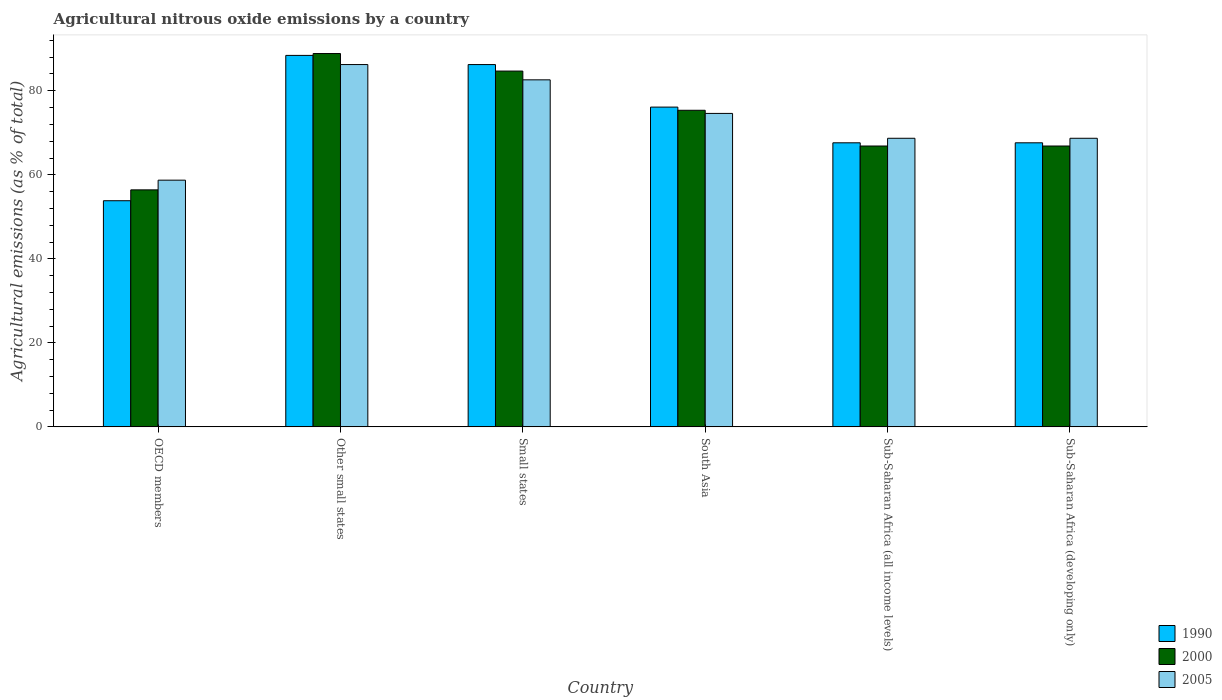Are the number of bars per tick equal to the number of legend labels?
Your response must be concise. Yes. Are the number of bars on each tick of the X-axis equal?
Your answer should be compact. Yes. How many bars are there on the 3rd tick from the left?
Make the answer very short. 3. What is the label of the 2nd group of bars from the left?
Offer a terse response. Other small states. In how many cases, is the number of bars for a given country not equal to the number of legend labels?
Provide a short and direct response. 0. What is the amount of agricultural nitrous oxide emitted in 2005 in OECD members?
Your response must be concise. 58.73. Across all countries, what is the maximum amount of agricultural nitrous oxide emitted in 1990?
Your answer should be compact. 88.42. Across all countries, what is the minimum amount of agricultural nitrous oxide emitted in 2005?
Your answer should be compact. 58.73. In which country was the amount of agricultural nitrous oxide emitted in 2005 maximum?
Provide a short and direct response. Other small states. In which country was the amount of agricultural nitrous oxide emitted in 2005 minimum?
Offer a terse response. OECD members. What is the total amount of agricultural nitrous oxide emitted in 2005 in the graph?
Make the answer very short. 439.59. What is the difference between the amount of agricultural nitrous oxide emitted in 1990 in South Asia and that in Sub-Saharan Africa (all income levels)?
Your answer should be very brief. 8.5. What is the difference between the amount of agricultural nitrous oxide emitted in 1990 in Sub-Saharan Africa (all income levels) and the amount of agricultural nitrous oxide emitted in 2005 in Sub-Saharan Africa (developing only)?
Provide a succinct answer. -1.08. What is the average amount of agricultural nitrous oxide emitted in 1990 per country?
Your response must be concise. 73.31. What is the difference between the amount of agricultural nitrous oxide emitted of/in 2005 and amount of agricultural nitrous oxide emitted of/in 2000 in Sub-Saharan Africa (developing only)?
Give a very brief answer. 1.84. In how many countries, is the amount of agricultural nitrous oxide emitted in 2000 greater than 32 %?
Your answer should be compact. 6. What is the ratio of the amount of agricultural nitrous oxide emitted in 2005 in South Asia to that in Sub-Saharan Africa (developing only)?
Your response must be concise. 1.09. Is the difference between the amount of agricultural nitrous oxide emitted in 2005 in Other small states and Sub-Saharan Africa (all income levels) greater than the difference between the amount of agricultural nitrous oxide emitted in 2000 in Other small states and Sub-Saharan Africa (all income levels)?
Provide a short and direct response. No. What is the difference between the highest and the second highest amount of agricultural nitrous oxide emitted in 2000?
Offer a terse response. 13.51. What is the difference between the highest and the lowest amount of agricultural nitrous oxide emitted in 2000?
Give a very brief answer. 32.45. In how many countries, is the amount of agricultural nitrous oxide emitted in 2000 greater than the average amount of agricultural nitrous oxide emitted in 2000 taken over all countries?
Provide a succinct answer. 3. What does the 2nd bar from the left in Sub-Saharan Africa (developing only) represents?
Give a very brief answer. 2000. What does the 2nd bar from the right in South Asia represents?
Your answer should be very brief. 2000. Is it the case that in every country, the sum of the amount of agricultural nitrous oxide emitted in 2005 and amount of agricultural nitrous oxide emitted in 2000 is greater than the amount of agricultural nitrous oxide emitted in 1990?
Give a very brief answer. Yes. How many bars are there?
Your answer should be very brief. 18. Are all the bars in the graph horizontal?
Keep it short and to the point. No. How many countries are there in the graph?
Offer a very short reply. 6. Does the graph contain grids?
Provide a short and direct response. No. How are the legend labels stacked?
Give a very brief answer. Vertical. What is the title of the graph?
Offer a terse response. Agricultural nitrous oxide emissions by a country. Does "1981" appear as one of the legend labels in the graph?
Offer a very short reply. No. What is the label or title of the X-axis?
Make the answer very short. Country. What is the label or title of the Y-axis?
Offer a terse response. Agricultural emissions (as % of total). What is the Agricultural emissions (as % of total) of 1990 in OECD members?
Make the answer very short. 53.83. What is the Agricultural emissions (as % of total) in 2000 in OECD members?
Ensure brevity in your answer.  56.42. What is the Agricultural emissions (as % of total) in 2005 in OECD members?
Make the answer very short. 58.73. What is the Agricultural emissions (as % of total) of 1990 in Other small states?
Your response must be concise. 88.42. What is the Agricultural emissions (as % of total) of 2000 in Other small states?
Provide a short and direct response. 88.87. What is the Agricultural emissions (as % of total) in 2005 in Other small states?
Give a very brief answer. 86.25. What is the Agricultural emissions (as % of total) of 1990 in Small states?
Make the answer very short. 86.24. What is the Agricultural emissions (as % of total) in 2000 in Small states?
Your response must be concise. 84.69. What is the Agricultural emissions (as % of total) in 2005 in Small states?
Provide a short and direct response. 82.61. What is the Agricultural emissions (as % of total) in 1990 in South Asia?
Ensure brevity in your answer.  76.12. What is the Agricultural emissions (as % of total) of 2000 in South Asia?
Offer a terse response. 75.36. What is the Agricultural emissions (as % of total) in 2005 in South Asia?
Your response must be concise. 74.62. What is the Agricultural emissions (as % of total) of 1990 in Sub-Saharan Africa (all income levels)?
Offer a very short reply. 67.62. What is the Agricultural emissions (as % of total) of 2000 in Sub-Saharan Africa (all income levels)?
Provide a short and direct response. 66.86. What is the Agricultural emissions (as % of total) in 2005 in Sub-Saharan Africa (all income levels)?
Make the answer very short. 68.7. What is the Agricultural emissions (as % of total) in 1990 in Sub-Saharan Africa (developing only)?
Offer a very short reply. 67.62. What is the Agricultural emissions (as % of total) of 2000 in Sub-Saharan Africa (developing only)?
Provide a short and direct response. 66.86. What is the Agricultural emissions (as % of total) of 2005 in Sub-Saharan Africa (developing only)?
Offer a very short reply. 68.7. Across all countries, what is the maximum Agricultural emissions (as % of total) in 1990?
Provide a succinct answer. 88.42. Across all countries, what is the maximum Agricultural emissions (as % of total) in 2000?
Provide a succinct answer. 88.87. Across all countries, what is the maximum Agricultural emissions (as % of total) in 2005?
Offer a very short reply. 86.25. Across all countries, what is the minimum Agricultural emissions (as % of total) of 1990?
Your response must be concise. 53.83. Across all countries, what is the minimum Agricultural emissions (as % of total) in 2000?
Provide a succinct answer. 56.42. Across all countries, what is the minimum Agricultural emissions (as % of total) of 2005?
Your answer should be compact. 58.73. What is the total Agricultural emissions (as % of total) in 1990 in the graph?
Keep it short and to the point. 439.86. What is the total Agricultural emissions (as % of total) in 2000 in the graph?
Offer a very short reply. 439.06. What is the total Agricultural emissions (as % of total) in 2005 in the graph?
Ensure brevity in your answer.  439.59. What is the difference between the Agricultural emissions (as % of total) in 1990 in OECD members and that in Other small states?
Your answer should be very brief. -34.59. What is the difference between the Agricultural emissions (as % of total) in 2000 in OECD members and that in Other small states?
Your response must be concise. -32.45. What is the difference between the Agricultural emissions (as % of total) in 2005 in OECD members and that in Other small states?
Provide a succinct answer. -27.52. What is the difference between the Agricultural emissions (as % of total) in 1990 in OECD members and that in Small states?
Your answer should be very brief. -32.41. What is the difference between the Agricultural emissions (as % of total) of 2000 in OECD members and that in Small states?
Offer a very short reply. -28.28. What is the difference between the Agricultural emissions (as % of total) of 2005 in OECD members and that in Small states?
Keep it short and to the point. -23.88. What is the difference between the Agricultural emissions (as % of total) of 1990 in OECD members and that in South Asia?
Give a very brief answer. -22.29. What is the difference between the Agricultural emissions (as % of total) of 2000 in OECD members and that in South Asia?
Your answer should be compact. -18.94. What is the difference between the Agricultural emissions (as % of total) in 2005 in OECD members and that in South Asia?
Keep it short and to the point. -15.89. What is the difference between the Agricultural emissions (as % of total) in 1990 in OECD members and that in Sub-Saharan Africa (all income levels)?
Offer a terse response. -13.79. What is the difference between the Agricultural emissions (as % of total) of 2000 in OECD members and that in Sub-Saharan Africa (all income levels)?
Ensure brevity in your answer.  -10.44. What is the difference between the Agricultural emissions (as % of total) in 2005 in OECD members and that in Sub-Saharan Africa (all income levels)?
Your answer should be compact. -9.97. What is the difference between the Agricultural emissions (as % of total) of 1990 in OECD members and that in Sub-Saharan Africa (developing only)?
Your answer should be very brief. -13.79. What is the difference between the Agricultural emissions (as % of total) in 2000 in OECD members and that in Sub-Saharan Africa (developing only)?
Give a very brief answer. -10.44. What is the difference between the Agricultural emissions (as % of total) of 2005 in OECD members and that in Sub-Saharan Africa (developing only)?
Your answer should be compact. -9.97. What is the difference between the Agricultural emissions (as % of total) of 1990 in Other small states and that in Small states?
Make the answer very short. 2.18. What is the difference between the Agricultural emissions (as % of total) in 2000 in Other small states and that in Small states?
Provide a succinct answer. 4.17. What is the difference between the Agricultural emissions (as % of total) of 2005 in Other small states and that in Small states?
Provide a succinct answer. 3.64. What is the difference between the Agricultural emissions (as % of total) of 1990 in Other small states and that in South Asia?
Ensure brevity in your answer.  12.31. What is the difference between the Agricultural emissions (as % of total) in 2000 in Other small states and that in South Asia?
Keep it short and to the point. 13.51. What is the difference between the Agricultural emissions (as % of total) in 2005 in Other small states and that in South Asia?
Your answer should be very brief. 11.63. What is the difference between the Agricultural emissions (as % of total) of 1990 in Other small states and that in Sub-Saharan Africa (all income levels)?
Provide a succinct answer. 20.8. What is the difference between the Agricultural emissions (as % of total) of 2000 in Other small states and that in Sub-Saharan Africa (all income levels)?
Provide a succinct answer. 22.01. What is the difference between the Agricultural emissions (as % of total) of 2005 in Other small states and that in Sub-Saharan Africa (all income levels)?
Offer a terse response. 17.55. What is the difference between the Agricultural emissions (as % of total) of 1990 in Other small states and that in Sub-Saharan Africa (developing only)?
Give a very brief answer. 20.8. What is the difference between the Agricultural emissions (as % of total) in 2000 in Other small states and that in Sub-Saharan Africa (developing only)?
Your response must be concise. 22.01. What is the difference between the Agricultural emissions (as % of total) of 2005 in Other small states and that in Sub-Saharan Africa (developing only)?
Give a very brief answer. 17.55. What is the difference between the Agricultural emissions (as % of total) of 1990 in Small states and that in South Asia?
Your answer should be compact. 10.12. What is the difference between the Agricultural emissions (as % of total) in 2000 in Small states and that in South Asia?
Offer a terse response. 9.33. What is the difference between the Agricultural emissions (as % of total) of 2005 in Small states and that in South Asia?
Your answer should be compact. 7.99. What is the difference between the Agricultural emissions (as % of total) of 1990 in Small states and that in Sub-Saharan Africa (all income levels)?
Your response must be concise. 18.62. What is the difference between the Agricultural emissions (as % of total) in 2000 in Small states and that in Sub-Saharan Africa (all income levels)?
Provide a succinct answer. 17.84. What is the difference between the Agricultural emissions (as % of total) in 2005 in Small states and that in Sub-Saharan Africa (all income levels)?
Your answer should be compact. 13.91. What is the difference between the Agricultural emissions (as % of total) in 1990 in Small states and that in Sub-Saharan Africa (developing only)?
Give a very brief answer. 18.62. What is the difference between the Agricultural emissions (as % of total) of 2000 in Small states and that in Sub-Saharan Africa (developing only)?
Offer a terse response. 17.84. What is the difference between the Agricultural emissions (as % of total) of 2005 in Small states and that in Sub-Saharan Africa (developing only)?
Provide a short and direct response. 13.91. What is the difference between the Agricultural emissions (as % of total) in 1990 in South Asia and that in Sub-Saharan Africa (all income levels)?
Provide a succinct answer. 8.5. What is the difference between the Agricultural emissions (as % of total) of 2000 in South Asia and that in Sub-Saharan Africa (all income levels)?
Offer a terse response. 8.5. What is the difference between the Agricultural emissions (as % of total) of 2005 in South Asia and that in Sub-Saharan Africa (all income levels)?
Make the answer very short. 5.92. What is the difference between the Agricultural emissions (as % of total) of 1990 in South Asia and that in Sub-Saharan Africa (developing only)?
Your answer should be compact. 8.5. What is the difference between the Agricultural emissions (as % of total) in 2000 in South Asia and that in Sub-Saharan Africa (developing only)?
Offer a very short reply. 8.5. What is the difference between the Agricultural emissions (as % of total) of 2005 in South Asia and that in Sub-Saharan Africa (developing only)?
Your answer should be compact. 5.92. What is the difference between the Agricultural emissions (as % of total) in 2005 in Sub-Saharan Africa (all income levels) and that in Sub-Saharan Africa (developing only)?
Offer a very short reply. 0. What is the difference between the Agricultural emissions (as % of total) of 1990 in OECD members and the Agricultural emissions (as % of total) of 2000 in Other small states?
Provide a short and direct response. -35.04. What is the difference between the Agricultural emissions (as % of total) in 1990 in OECD members and the Agricultural emissions (as % of total) in 2005 in Other small states?
Your answer should be very brief. -32.41. What is the difference between the Agricultural emissions (as % of total) in 2000 in OECD members and the Agricultural emissions (as % of total) in 2005 in Other small states?
Offer a very short reply. -29.83. What is the difference between the Agricultural emissions (as % of total) of 1990 in OECD members and the Agricultural emissions (as % of total) of 2000 in Small states?
Your response must be concise. -30.86. What is the difference between the Agricultural emissions (as % of total) of 1990 in OECD members and the Agricultural emissions (as % of total) of 2005 in Small states?
Ensure brevity in your answer.  -28.78. What is the difference between the Agricultural emissions (as % of total) of 2000 in OECD members and the Agricultural emissions (as % of total) of 2005 in Small states?
Provide a short and direct response. -26.19. What is the difference between the Agricultural emissions (as % of total) in 1990 in OECD members and the Agricultural emissions (as % of total) in 2000 in South Asia?
Offer a terse response. -21.53. What is the difference between the Agricultural emissions (as % of total) of 1990 in OECD members and the Agricultural emissions (as % of total) of 2005 in South Asia?
Give a very brief answer. -20.78. What is the difference between the Agricultural emissions (as % of total) in 2000 in OECD members and the Agricultural emissions (as % of total) in 2005 in South Asia?
Your response must be concise. -18.2. What is the difference between the Agricultural emissions (as % of total) of 1990 in OECD members and the Agricultural emissions (as % of total) of 2000 in Sub-Saharan Africa (all income levels)?
Provide a short and direct response. -13.03. What is the difference between the Agricultural emissions (as % of total) in 1990 in OECD members and the Agricultural emissions (as % of total) in 2005 in Sub-Saharan Africa (all income levels)?
Your answer should be compact. -14.86. What is the difference between the Agricultural emissions (as % of total) in 2000 in OECD members and the Agricultural emissions (as % of total) in 2005 in Sub-Saharan Africa (all income levels)?
Provide a short and direct response. -12.28. What is the difference between the Agricultural emissions (as % of total) in 1990 in OECD members and the Agricultural emissions (as % of total) in 2000 in Sub-Saharan Africa (developing only)?
Offer a very short reply. -13.03. What is the difference between the Agricultural emissions (as % of total) in 1990 in OECD members and the Agricultural emissions (as % of total) in 2005 in Sub-Saharan Africa (developing only)?
Offer a very short reply. -14.86. What is the difference between the Agricultural emissions (as % of total) of 2000 in OECD members and the Agricultural emissions (as % of total) of 2005 in Sub-Saharan Africa (developing only)?
Give a very brief answer. -12.28. What is the difference between the Agricultural emissions (as % of total) of 1990 in Other small states and the Agricultural emissions (as % of total) of 2000 in Small states?
Your response must be concise. 3.73. What is the difference between the Agricultural emissions (as % of total) of 1990 in Other small states and the Agricultural emissions (as % of total) of 2005 in Small states?
Ensure brevity in your answer.  5.82. What is the difference between the Agricultural emissions (as % of total) of 2000 in Other small states and the Agricultural emissions (as % of total) of 2005 in Small states?
Provide a short and direct response. 6.26. What is the difference between the Agricultural emissions (as % of total) of 1990 in Other small states and the Agricultural emissions (as % of total) of 2000 in South Asia?
Your answer should be very brief. 13.06. What is the difference between the Agricultural emissions (as % of total) of 1990 in Other small states and the Agricultural emissions (as % of total) of 2005 in South Asia?
Your answer should be compact. 13.81. What is the difference between the Agricultural emissions (as % of total) in 2000 in Other small states and the Agricultural emissions (as % of total) in 2005 in South Asia?
Your answer should be compact. 14.25. What is the difference between the Agricultural emissions (as % of total) of 1990 in Other small states and the Agricultural emissions (as % of total) of 2000 in Sub-Saharan Africa (all income levels)?
Your answer should be very brief. 21.57. What is the difference between the Agricultural emissions (as % of total) of 1990 in Other small states and the Agricultural emissions (as % of total) of 2005 in Sub-Saharan Africa (all income levels)?
Give a very brief answer. 19.73. What is the difference between the Agricultural emissions (as % of total) of 2000 in Other small states and the Agricultural emissions (as % of total) of 2005 in Sub-Saharan Africa (all income levels)?
Offer a terse response. 20.17. What is the difference between the Agricultural emissions (as % of total) in 1990 in Other small states and the Agricultural emissions (as % of total) in 2000 in Sub-Saharan Africa (developing only)?
Provide a succinct answer. 21.57. What is the difference between the Agricultural emissions (as % of total) in 1990 in Other small states and the Agricultural emissions (as % of total) in 2005 in Sub-Saharan Africa (developing only)?
Ensure brevity in your answer.  19.73. What is the difference between the Agricultural emissions (as % of total) of 2000 in Other small states and the Agricultural emissions (as % of total) of 2005 in Sub-Saharan Africa (developing only)?
Keep it short and to the point. 20.17. What is the difference between the Agricultural emissions (as % of total) of 1990 in Small states and the Agricultural emissions (as % of total) of 2000 in South Asia?
Offer a very short reply. 10.88. What is the difference between the Agricultural emissions (as % of total) of 1990 in Small states and the Agricultural emissions (as % of total) of 2005 in South Asia?
Your answer should be very brief. 11.63. What is the difference between the Agricultural emissions (as % of total) of 2000 in Small states and the Agricultural emissions (as % of total) of 2005 in South Asia?
Your answer should be very brief. 10.08. What is the difference between the Agricultural emissions (as % of total) in 1990 in Small states and the Agricultural emissions (as % of total) in 2000 in Sub-Saharan Africa (all income levels)?
Your answer should be very brief. 19.39. What is the difference between the Agricultural emissions (as % of total) of 1990 in Small states and the Agricultural emissions (as % of total) of 2005 in Sub-Saharan Africa (all income levels)?
Offer a terse response. 17.55. What is the difference between the Agricultural emissions (as % of total) in 2000 in Small states and the Agricultural emissions (as % of total) in 2005 in Sub-Saharan Africa (all income levels)?
Make the answer very short. 16. What is the difference between the Agricultural emissions (as % of total) of 1990 in Small states and the Agricultural emissions (as % of total) of 2000 in Sub-Saharan Africa (developing only)?
Offer a very short reply. 19.39. What is the difference between the Agricultural emissions (as % of total) of 1990 in Small states and the Agricultural emissions (as % of total) of 2005 in Sub-Saharan Africa (developing only)?
Ensure brevity in your answer.  17.55. What is the difference between the Agricultural emissions (as % of total) of 2000 in Small states and the Agricultural emissions (as % of total) of 2005 in Sub-Saharan Africa (developing only)?
Offer a very short reply. 16. What is the difference between the Agricultural emissions (as % of total) in 1990 in South Asia and the Agricultural emissions (as % of total) in 2000 in Sub-Saharan Africa (all income levels)?
Your answer should be compact. 9.26. What is the difference between the Agricultural emissions (as % of total) of 1990 in South Asia and the Agricultural emissions (as % of total) of 2005 in Sub-Saharan Africa (all income levels)?
Keep it short and to the point. 7.42. What is the difference between the Agricultural emissions (as % of total) in 2000 in South Asia and the Agricultural emissions (as % of total) in 2005 in Sub-Saharan Africa (all income levels)?
Keep it short and to the point. 6.67. What is the difference between the Agricultural emissions (as % of total) in 1990 in South Asia and the Agricultural emissions (as % of total) in 2000 in Sub-Saharan Africa (developing only)?
Your response must be concise. 9.26. What is the difference between the Agricultural emissions (as % of total) in 1990 in South Asia and the Agricultural emissions (as % of total) in 2005 in Sub-Saharan Africa (developing only)?
Your answer should be compact. 7.42. What is the difference between the Agricultural emissions (as % of total) of 2000 in South Asia and the Agricultural emissions (as % of total) of 2005 in Sub-Saharan Africa (developing only)?
Offer a very short reply. 6.67. What is the difference between the Agricultural emissions (as % of total) of 1990 in Sub-Saharan Africa (all income levels) and the Agricultural emissions (as % of total) of 2000 in Sub-Saharan Africa (developing only)?
Your answer should be very brief. 0.76. What is the difference between the Agricultural emissions (as % of total) in 1990 in Sub-Saharan Africa (all income levels) and the Agricultural emissions (as % of total) in 2005 in Sub-Saharan Africa (developing only)?
Your answer should be very brief. -1.08. What is the difference between the Agricultural emissions (as % of total) of 2000 in Sub-Saharan Africa (all income levels) and the Agricultural emissions (as % of total) of 2005 in Sub-Saharan Africa (developing only)?
Ensure brevity in your answer.  -1.84. What is the average Agricultural emissions (as % of total) in 1990 per country?
Your answer should be very brief. 73.31. What is the average Agricultural emissions (as % of total) of 2000 per country?
Your answer should be compact. 73.18. What is the average Agricultural emissions (as % of total) of 2005 per country?
Provide a succinct answer. 73.27. What is the difference between the Agricultural emissions (as % of total) of 1990 and Agricultural emissions (as % of total) of 2000 in OECD members?
Your answer should be very brief. -2.59. What is the difference between the Agricultural emissions (as % of total) of 1990 and Agricultural emissions (as % of total) of 2005 in OECD members?
Your response must be concise. -4.9. What is the difference between the Agricultural emissions (as % of total) in 2000 and Agricultural emissions (as % of total) in 2005 in OECD members?
Offer a terse response. -2.31. What is the difference between the Agricultural emissions (as % of total) in 1990 and Agricultural emissions (as % of total) in 2000 in Other small states?
Your answer should be compact. -0.44. What is the difference between the Agricultural emissions (as % of total) of 1990 and Agricultural emissions (as % of total) of 2005 in Other small states?
Your answer should be compact. 2.18. What is the difference between the Agricultural emissions (as % of total) of 2000 and Agricultural emissions (as % of total) of 2005 in Other small states?
Keep it short and to the point. 2.62. What is the difference between the Agricultural emissions (as % of total) in 1990 and Agricultural emissions (as % of total) in 2000 in Small states?
Keep it short and to the point. 1.55. What is the difference between the Agricultural emissions (as % of total) of 1990 and Agricultural emissions (as % of total) of 2005 in Small states?
Your answer should be very brief. 3.64. What is the difference between the Agricultural emissions (as % of total) in 2000 and Agricultural emissions (as % of total) in 2005 in Small states?
Keep it short and to the point. 2.09. What is the difference between the Agricultural emissions (as % of total) in 1990 and Agricultural emissions (as % of total) in 2000 in South Asia?
Your answer should be very brief. 0.76. What is the difference between the Agricultural emissions (as % of total) in 1990 and Agricultural emissions (as % of total) in 2005 in South Asia?
Give a very brief answer. 1.5. What is the difference between the Agricultural emissions (as % of total) of 2000 and Agricultural emissions (as % of total) of 2005 in South Asia?
Keep it short and to the point. 0.75. What is the difference between the Agricultural emissions (as % of total) of 1990 and Agricultural emissions (as % of total) of 2000 in Sub-Saharan Africa (all income levels)?
Offer a very short reply. 0.76. What is the difference between the Agricultural emissions (as % of total) in 1990 and Agricultural emissions (as % of total) in 2005 in Sub-Saharan Africa (all income levels)?
Your response must be concise. -1.08. What is the difference between the Agricultural emissions (as % of total) in 2000 and Agricultural emissions (as % of total) in 2005 in Sub-Saharan Africa (all income levels)?
Your answer should be very brief. -1.84. What is the difference between the Agricultural emissions (as % of total) in 1990 and Agricultural emissions (as % of total) in 2000 in Sub-Saharan Africa (developing only)?
Your response must be concise. 0.76. What is the difference between the Agricultural emissions (as % of total) of 1990 and Agricultural emissions (as % of total) of 2005 in Sub-Saharan Africa (developing only)?
Make the answer very short. -1.08. What is the difference between the Agricultural emissions (as % of total) of 2000 and Agricultural emissions (as % of total) of 2005 in Sub-Saharan Africa (developing only)?
Your answer should be compact. -1.84. What is the ratio of the Agricultural emissions (as % of total) of 1990 in OECD members to that in Other small states?
Ensure brevity in your answer.  0.61. What is the ratio of the Agricultural emissions (as % of total) of 2000 in OECD members to that in Other small states?
Make the answer very short. 0.63. What is the ratio of the Agricultural emissions (as % of total) in 2005 in OECD members to that in Other small states?
Keep it short and to the point. 0.68. What is the ratio of the Agricultural emissions (as % of total) in 1990 in OECD members to that in Small states?
Make the answer very short. 0.62. What is the ratio of the Agricultural emissions (as % of total) of 2000 in OECD members to that in Small states?
Provide a succinct answer. 0.67. What is the ratio of the Agricultural emissions (as % of total) in 2005 in OECD members to that in Small states?
Keep it short and to the point. 0.71. What is the ratio of the Agricultural emissions (as % of total) of 1990 in OECD members to that in South Asia?
Keep it short and to the point. 0.71. What is the ratio of the Agricultural emissions (as % of total) in 2000 in OECD members to that in South Asia?
Offer a very short reply. 0.75. What is the ratio of the Agricultural emissions (as % of total) in 2005 in OECD members to that in South Asia?
Your answer should be very brief. 0.79. What is the ratio of the Agricultural emissions (as % of total) of 1990 in OECD members to that in Sub-Saharan Africa (all income levels)?
Your answer should be very brief. 0.8. What is the ratio of the Agricultural emissions (as % of total) of 2000 in OECD members to that in Sub-Saharan Africa (all income levels)?
Keep it short and to the point. 0.84. What is the ratio of the Agricultural emissions (as % of total) in 2005 in OECD members to that in Sub-Saharan Africa (all income levels)?
Offer a very short reply. 0.85. What is the ratio of the Agricultural emissions (as % of total) in 1990 in OECD members to that in Sub-Saharan Africa (developing only)?
Your answer should be compact. 0.8. What is the ratio of the Agricultural emissions (as % of total) in 2000 in OECD members to that in Sub-Saharan Africa (developing only)?
Give a very brief answer. 0.84. What is the ratio of the Agricultural emissions (as % of total) of 2005 in OECD members to that in Sub-Saharan Africa (developing only)?
Your response must be concise. 0.85. What is the ratio of the Agricultural emissions (as % of total) of 1990 in Other small states to that in Small states?
Provide a succinct answer. 1.03. What is the ratio of the Agricultural emissions (as % of total) in 2000 in Other small states to that in Small states?
Offer a terse response. 1.05. What is the ratio of the Agricultural emissions (as % of total) of 2005 in Other small states to that in Small states?
Your answer should be very brief. 1.04. What is the ratio of the Agricultural emissions (as % of total) in 1990 in Other small states to that in South Asia?
Keep it short and to the point. 1.16. What is the ratio of the Agricultural emissions (as % of total) of 2000 in Other small states to that in South Asia?
Make the answer very short. 1.18. What is the ratio of the Agricultural emissions (as % of total) of 2005 in Other small states to that in South Asia?
Provide a short and direct response. 1.16. What is the ratio of the Agricultural emissions (as % of total) of 1990 in Other small states to that in Sub-Saharan Africa (all income levels)?
Your response must be concise. 1.31. What is the ratio of the Agricultural emissions (as % of total) of 2000 in Other small states to that in Sub-Saharan Africa (all income levels)?
Provide a succinct answer. 1.33. What is the ratio of the Agricultural emissions (as % of total) in 2005 in Other small states to that in Sub-Saharan Africa (all income levels)?
Your response must be concise. 1.26. What is the ratio of the Agricultural emissions (as % of total) of 1990 in Other small states to that in Sub-Saharan Africa (developing only)?
Make the answer very short. 1.31. What is the ratio of the Agricultural emissions (as % of total) of 2000 in Other small states to that in Sub-Saharan Africa (developing only)?
Your answer should be very brief. 1.33. What is the ratio of the Agricultural emissions (as % of total) of 2005 in Other small states to that in Sub-Saharan Africa (developing only)?
Your response must be concise. 1.26. What is the ratio of the Agricultural emissions (as % of total) of 1990 in Small states to that in South Asia?
Provide a short and direct response. 1.13. What is the ratio of the Agricultural emissions (as % of total) in 2000 in Small states to that in South Asia?
Your answer should be compact. 1.12. What is the ratio of the Agricultural emissions (as % of total) in 2005 in Small states to that in South Asia?
Offer a very short reply. 1.11. What is the ratio of the Agricultural emissions (as % of total) in 1990 in Small states to that in Sub-Saharan Africa (all income levels)?
Your answer should be compact. 1.28. What is the ratio of the Agricultural emissions (as % of total) in 2000 in Small states to that in Sub-Saharan Africa (all income levels)?
Give a very brief answer. 1.27. What is the ratio of the Agricultural emissions (as % of total) of 2005 in Small states to that in Sub-Saharan Africa (all income levels)?
Your response must be concise. 1.2. What is the ratio of the Agricultural emissions (as % of total) of 1990 in Small states to that in Sub-Saharan Africa (developing only)?
Provide a short and direct response. 1.28. What is the ratio of the Agricultural emissions (as % of total) in 2000 in Small states to that in Sub-Saharan Africa (developing only)?
Provide a short and direct response. 1.27. What is the ratio of the Agricultural emissions (as % of total) in 2005 in Small states to that in Sub-Saharan Africa (developing only)?
Provide a short and direct response. 1.2. What is the ratio of the Agricultural emissions (as % of total) in 1990 in South Asia to that in Sub-Saharan Africa (all income levels)?
Your answer should be compact. 1.13. What is the ratio of the Agricultural emissions (as % of total) of 2000 in South Asia to that in Sub-Saharan Africa (all income levels)?
Keep it short and to the point. 1.13. What is the ratio of the Agricultural emissions (as % of total) of 2005 in South Asia to that in Sub-Saharan Africa (all income levels)?
Offer a terse response. 1.09. What is the ratio of the Agricultural emissions (as % of total) in 1990 in South Asia to that in Sub-Saharan Africa (developing only)?
Provide a succinct answer. 1.13. What is the ratio of the Agricultural emissions (as % of total) in 2000 in South Asia to that in Sub-Saharan Africa (developing only)?
Ensure brevity in your answer.  1.13. What is the ratio of the Agricultural emissions (as % of total) in 2005 in South Asia to that in Sub-Saharan Africa (developing only)?
Your response must be concise. 1.09. What is the ratio of the Agricultural emissions (as % of total) in 2000 in Sub-Saharan Africa (all income levels) to that in Sub-Saharan Africa (developing only)?
Your response must be concise. 1. What is the ratio of the Agricultural emissions (as % of total) in 2005 in Sub-Saharan Africa (all income levels) to that in Sub-Saharan Africa (developing only)?
Offer a very short reply. 1. What is the difference between the highest and the second highest Agricultural emissions (as % of total) of 1990?
Provide a short and direct response. 2.18. What is the difference between the highest and the second highest Agricultural emissions (as % of total) in 2000?
Provide a short and direct response. 4.17. What is the difference between the highest and the second highest Agricultural emissions (as % of total) in 2005?
Make the answer very short. 3.64. What is the difference between the highest and the lowest Agricultural emissions (as % of total) of 1990?
Provide a succinct answer. 34.59. What is the difference between the highest and the lowest Agricultural emissions (as % of total) of 2000?
Your answer should be very brief. 32.45. What is the difference between the highest and the lowest Agricultural emissions (as % of total) in 2005?
Provide a short and direct response. 27.52. 